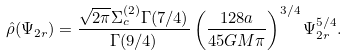<formula> <loc_0><loc_0><loc_500><loc_500>\hat { \rho } ( \Psi _ { 2 r } ) = \frac { \sqrt { 2 \pi } \Sigma _ { c } ^ { ( 2 ) } \Gamma ( 7 / 4 ) } { \Gamma ( 9 / 4 ) } \left ( \frac { 1 2 8 a } { 4 5 G M \pi } \right ) ^ { 3 / 4 } \Psi _ { 2 r } ^ { 5 / 4 } .</formula> 